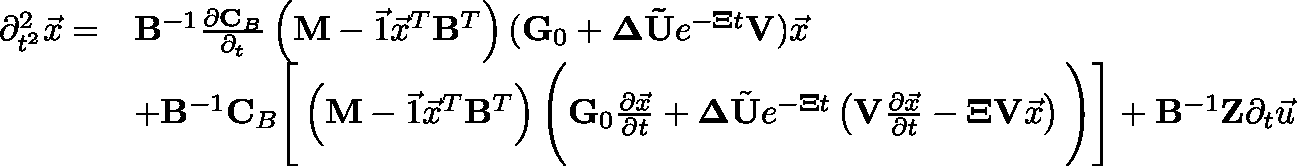Convert formula to latex. <formula><loc_0><loc_0><loc_500><loc_500>\begin{array} { r l } { \partial _ { t ^ { 2 } } ^ { 2 } \vec { x } = } & { B ^ { - 1 } \frac { \partial C _ { B } } { \partial _ { t } } \left ( M - \vec { 1 } \vec { x } ^ { T } B ^ { T } \right ) ( G _ { 0 } + \Delta \tilde { U } e ^ { - \Xi t } V ) \vec { x } } \\ & { + B ^ { - 1 } C _ { B } \left [ \left ( M - \vec { 1 } \vec { x } ^ { T } B ^ { T } \right ) \left ( G _ { 0 } \frac { \partial \vec { x } } { \partial t } + \Delta \tilde { U } e ^ { - \Xi t } \left ( V \frac { \partial \vec { x } } { \partial t } - \Xi V \vec { x } \right ) \right ) \right ] + B ^ { - 1 } Z \partial _ { t } \vec { u } } \end{array}</formula> 